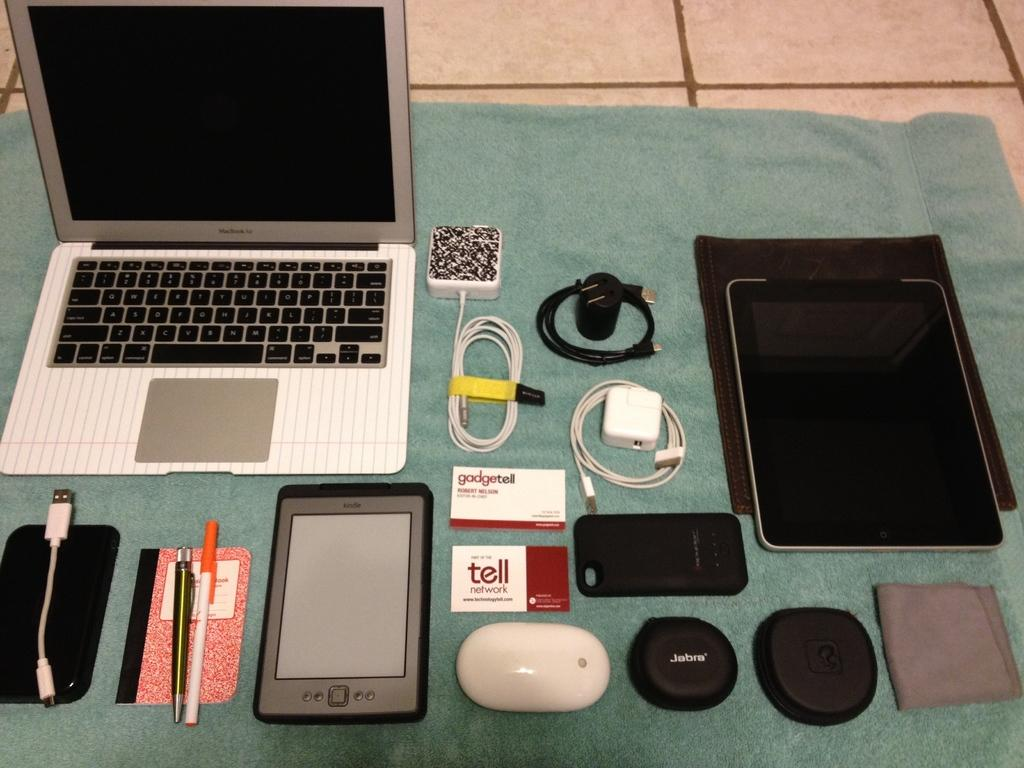<image>
Summarize the visual content of the image. An apple branded mac booik pro is sitting next to several peripherals for it. 